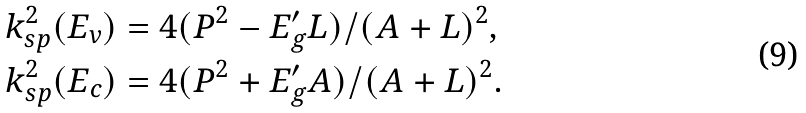Convert formula to latex. <formula><loc_0><loc_0><loc_500><loc_500>k _ { s p } ^ { 2 } ( E _ { v } ) & = 4 ( P ^ { 2 } - E _ { g } ^ { \prime } L ) / ( A + L ) ^ { 2 } , \\ k _ { s p } ^ { 2 } ( E _ { c } ) & = 4 ( P ^ { 2 } + E _ { g } ^ { \prime } A ) / ( A + L ) ^ { 2 } .</formula> 